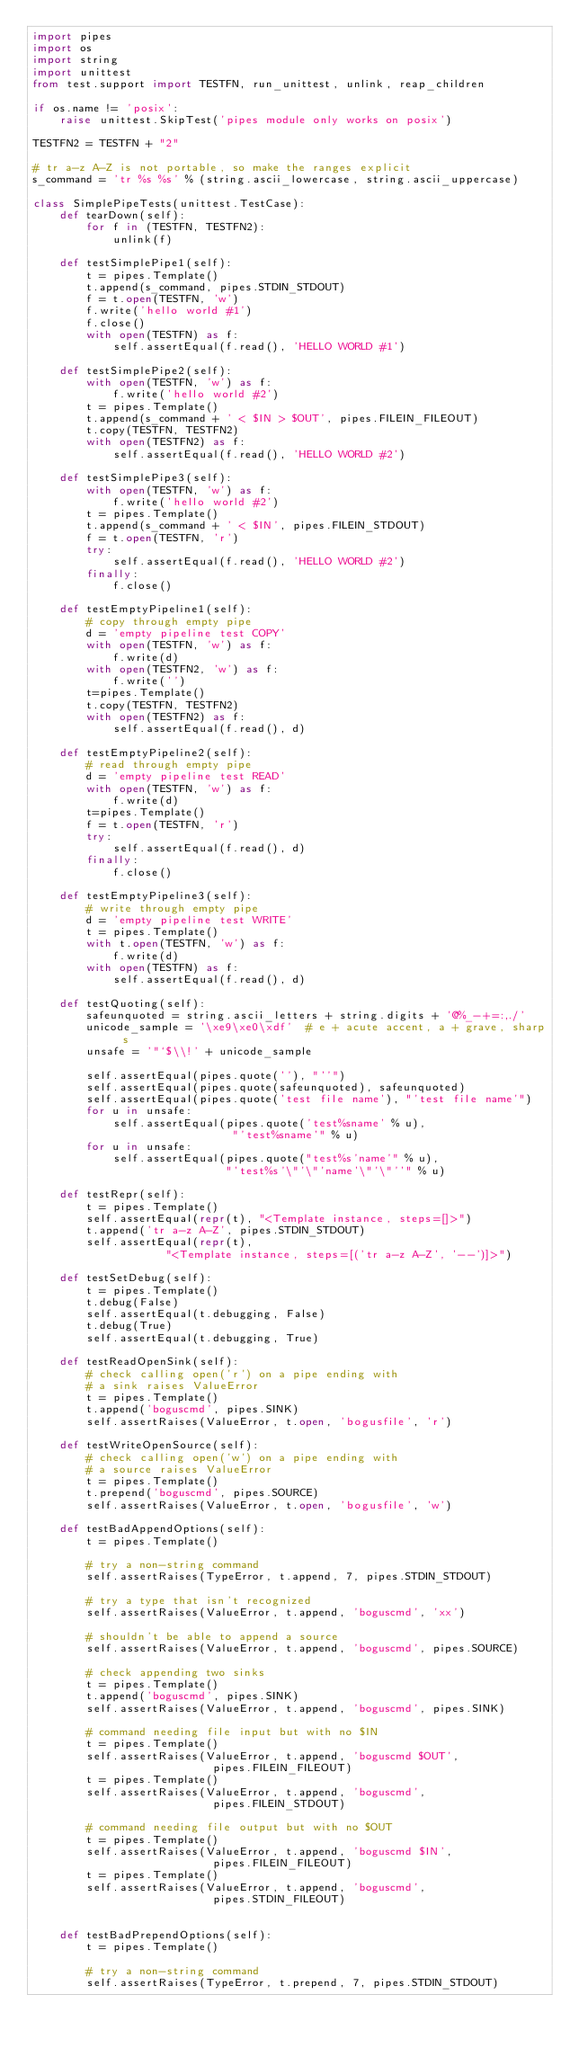<code> <loc_0><loc_0><loc_500><loc_500><_Python_>import pipes
import os
import string
import unittest
from test.support import TESTFN, run_unittest, unlink, reap_children

if os.name != 'posix':
    raise unittest.SkipTest('pipes module only works on posix')

TESTFN2 = TESTFN + "2"

# tr a-z A-Z is not portable, so make the ranges explicit
s_command = 'tr %s %s' % (string.ascii_lowercase, string.ascii_uppercase)

class SimplePipeTests(unittest.TestCase):
    def tearDown(self):
        for f in (TESTFN, TESTFN2):
            unlink(f)

    def testSimplePipe1(self):
        t = pipes.Template()
        t.append(s_command, pipes.STDIN_STDOUT)
        f = t.open(TESTFN, 'w')
        f.write('hello world #1')
        f.close()
        with open(TESTFN) as f:
            self.assertEqual(f.read(), 'HELLO WORLD #1')

    def testSimplePipe2(self):
        with open(TESTFN, 'w') as f:
            f.write('hello world #2')
        t = pipes.Template()
        t.append(s_command + ' < $IN > $OUT', pipes.FILEIN_FILEOUT)
        t.copy(TESTFN, TESTFN2)
        with open(TESTFN2) as f:
            self.assertEqual(f.read(), 'HELLO WORLD #2')

    def testSimplePipe3(self):
        with open(TESTFN, 'w') as f:
            f.write('hello world #2')
        t = pipes.Template()
        t.append(s_command + ' < $IN', pipes.FILEIN_STDOUT)
        f = t.open(TESTFN, 'r')
        try:
            self.assertEqual(f.read(), 'HELLO WORLD #2')
        finally:
            f.close()

    def testEmptyPipeline1(self):
        # copy through empty pipe
        d = 'empty pipeline test COPY'
        with open(TESTFN, 'w') as f:
            f.write(d)
        with open(TESTFN2, 'w') as f:
            f.write('')
        t=pipes.Template()
        t.copy(TESTFN, TESTFN2)
        with open(TESTFN2) as f:
            self.assertEqual(f.read(), d)

    def testEmptyPipeline2(self):
        # read through empty pipe
        d = 'empty pipeline test READ'
        with open(TESTFN, 'w') as f:
            f.write(d)
        t=pipes.Template()
        f = t.open(TESTFN, 'r')
        try:
            self.assertEqual(f.read(), d)
        finally:
            f.close()

    def testEmptyPipeline3(self):
        # write through empty pipe
        d = 'empty pipeline test WRITE'
        t = pipes.Template()
        with t.open(TESTFN, 'w') as f:
            f.write(d)
        with open(TESTFN) as f:
            self.assertEqual(f.read(), d)

    def testQuoting(self):
        safeunquoted = string.ascii_letters + string.digits + '@%_-+=:,./'
        unicode_sample = '\xe9\xe0\xdf'  # e + acute accent, a + grave, sharp s
        unsafe = '"`$\\!' + unicode_sample

        self.assertEqual(pipes.quote(''), "''")
        self.assertEqual(pipes.quote(safeunquoted), safeunquoted)
        self.assertEqual(pipes.quote('test file name'), "'test file name'")
        for u in unsafe:
            self.assertEqual(pipes.quote('test%sname' % u),
                              "'test%sname'" % u)
        for u in unsafe:
            self.assertEqual(pipes.quote("test%s'name'" % u),
                             "'test%s'\"'\"'name'\"'\"''" % u)

    def testRepr(self):
        t = pipes.Template()
        self.assertEqual(repr(t), "<Template instance, steps=[]>")
        t.append('tr a-z A-Z', pipes.STDIN_STDOUT)
        self.assertEqual(repr(t),
                    "<Template instance, steps=[('tr a-z A-Z', '--')]>")

    def testSetDebug(self):
        t = pipes.Template()
        t.debug(False)
        self.assertEqual(t.debugging, False)
        t.debug(True)
        self.assertEqual(t.debugging, True)

    def testReadOpenSink(self):
        # check calling open('r') on a pipe ending with
        # a sink raises ValueError
        t = pipes.Template()
        t.append('boguscmd', pipes.SINK)
        self.assertRaises(ValueError, t.open, 'bogusfile', 'r')

    def testWriteOpenSource(self):
        # check calling open('w') on a pipe ending with
        # a source raises ValueError
        t = pipes.Template()
        t.prepend('boguscmd', pipes.SOURCE)
        self.assertRaises(ValueError, t.open, 'bogusfile', 'w')

    def testBadAppendOptions(self):
        t = pipes.Template()

        # try a non-string command
        self.assertRaises(TypeError, t.append, 7, pipes.STDIN_STDOUT)

        # try a type that isn't recognized
        self.assertRaises(ValueError, t.append, 'boguscmd', 'xx')

        # shouldn't be able to append a source
        self.assertRaises(ValueError, t.append, 'boguscmd', pipes.SOURCE)

        # check appending two sinks
        t = pipes.Template()
        t.append('boguscmd', pipes.SINK)
        self.assertRaises(ValueError, t.append, 'boguscmd', pipes.SINK)

        # command needing file input but with no $IN
        t = pipes.Template()
        self.assertRaises(ValueError, t.append, 'boguscmd $OUT',
                           pipes.FILEIN_FILEOUT)
        t = pipes.Template()
        self.assertRaises(ValueError, t.append, 'boguscmd',
                           pipes.FILEIN_STDOUT)

        # command needing file output but with no $OUT
        t = pipes.Template()
        self.assertRaises(ValueError, t.append, 'boguscmd $IN',
                           pipes.FILEIN_FILEOUT)
        t = pipes.Template()
        self.assertRaises(ValueError, t.append, 'boguscmd',
                           pipes.STDIN_FILEOUT)


    def testBadPrependOptions(self):
        t = pipes.Template()

        # try a non-string command
        self.assertRaises(TypeError, t.prepend, 7, pipes.STDIN_STDOUT)
</code> 